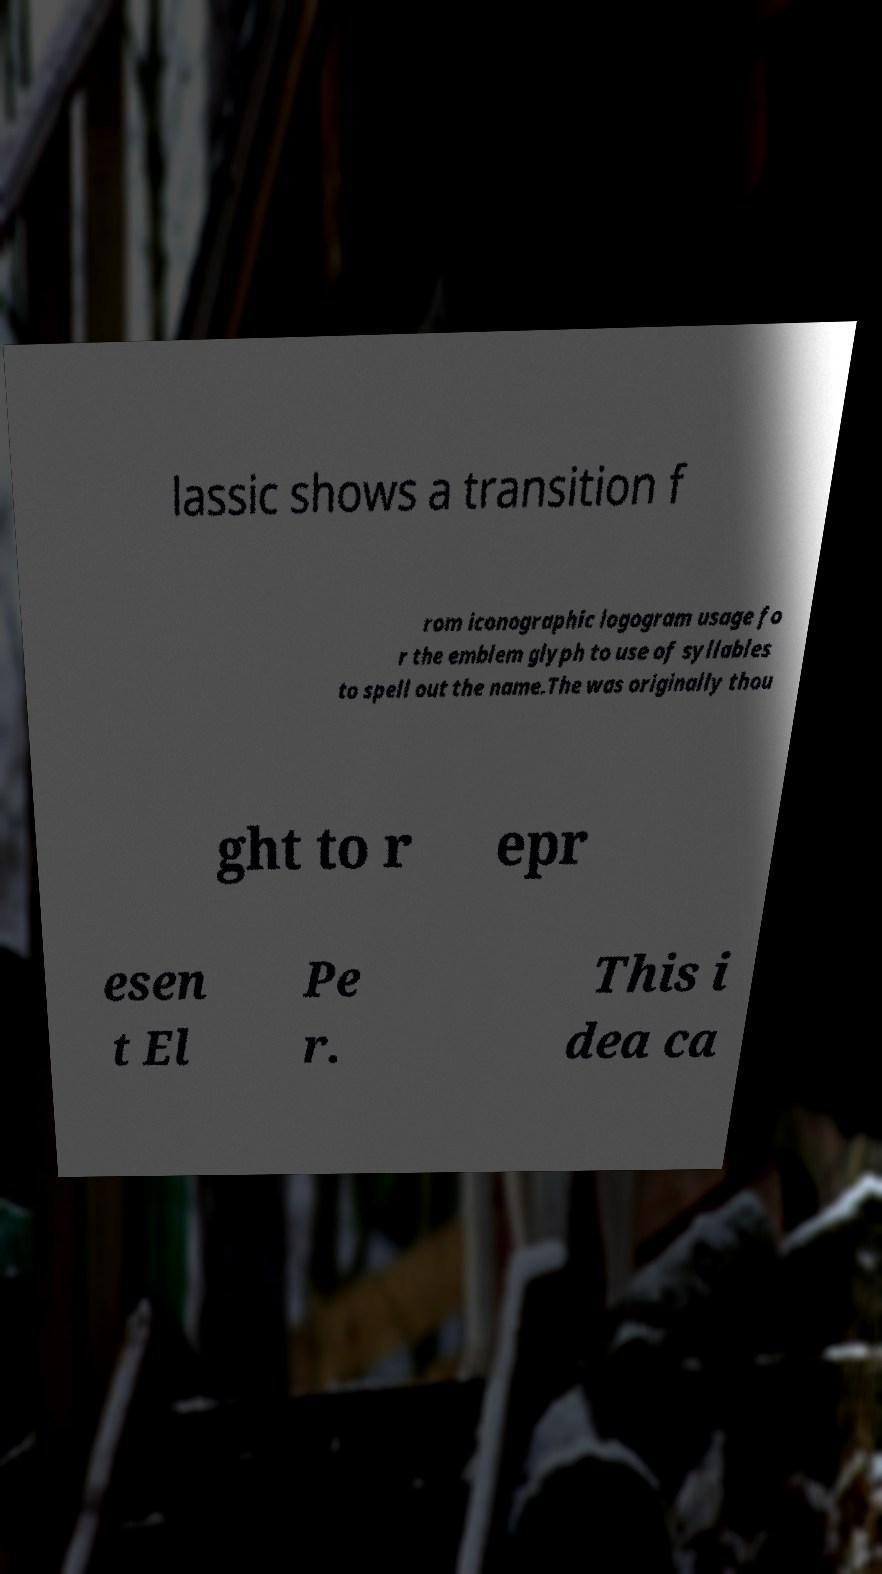Can you read and provide the text displayed in the image?This photo seems to have some interesting text. Can you extract and type it out for me? lassic shows a transition f rom iconographic logogram usage fo r the emblem glyph to use of syllables to spell out the name.The was originally thou ght to r epr esen t El Pe r. This i dea ca 